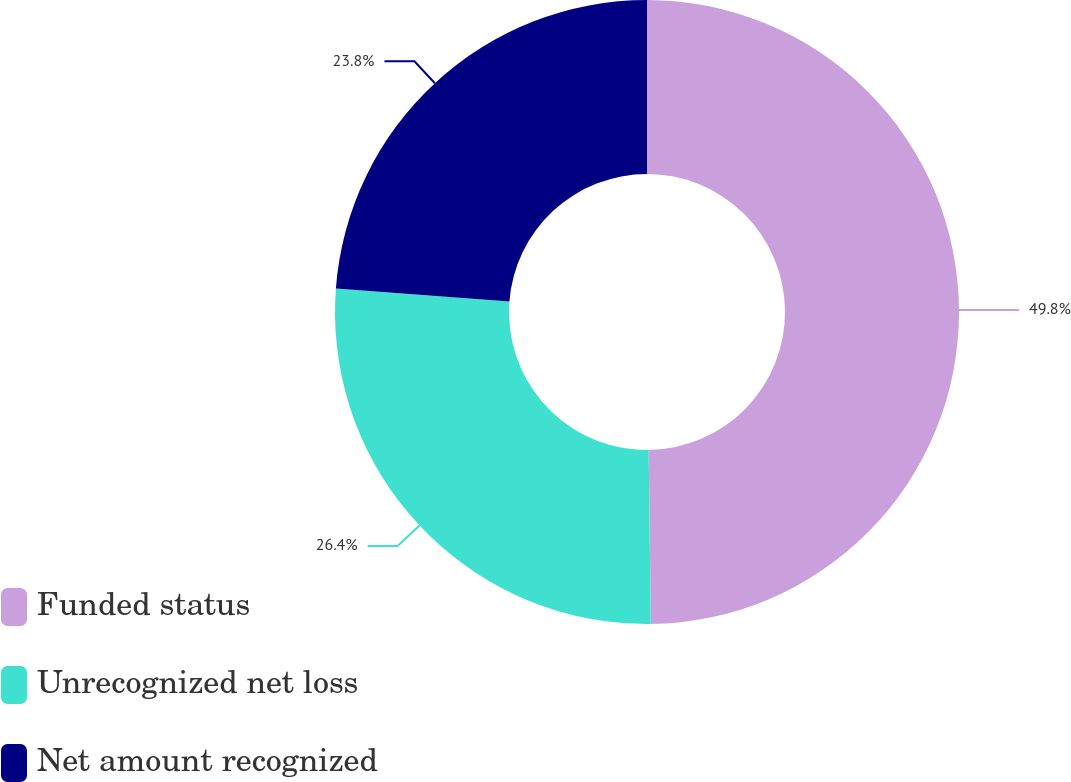Convert chart to OTSL. <chart><loc_0><loc_0><loc_500><loc_500><pie_chart><fcel>Funded status<fcel>Unrecognized net loss<fcel>Net amount recognized<nl><fcel>49.81%<fcel>26.4%<fcel>23.8%<nl></chart> 